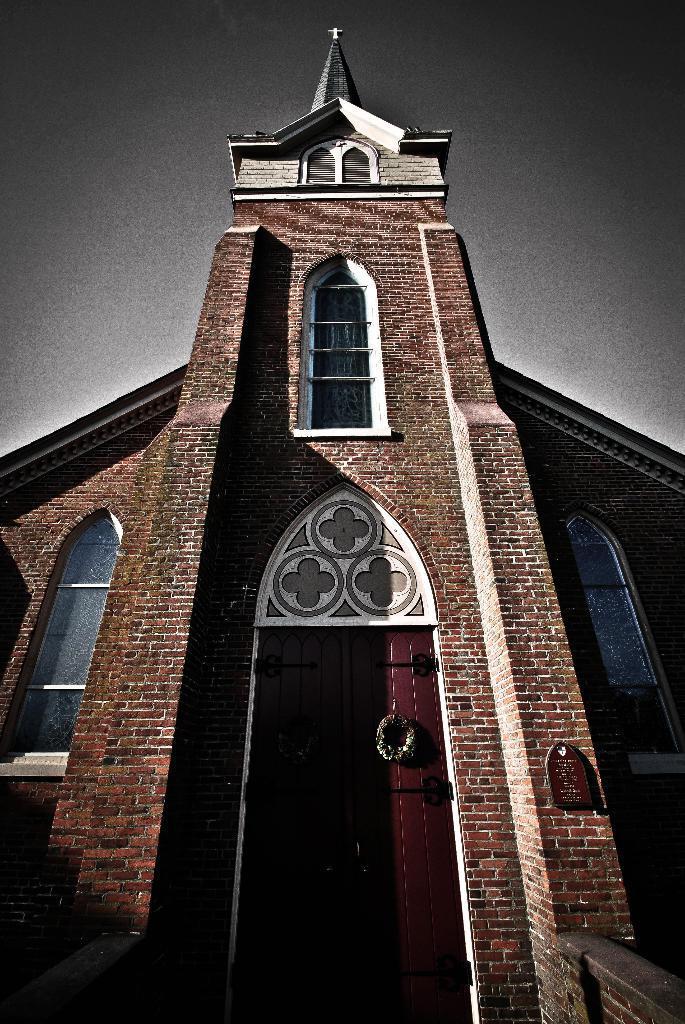Could you give a brief overview of what you see in this image? In this image we can see a building, windows, doors, board on the wall, cross symbol on the building and the sky. 